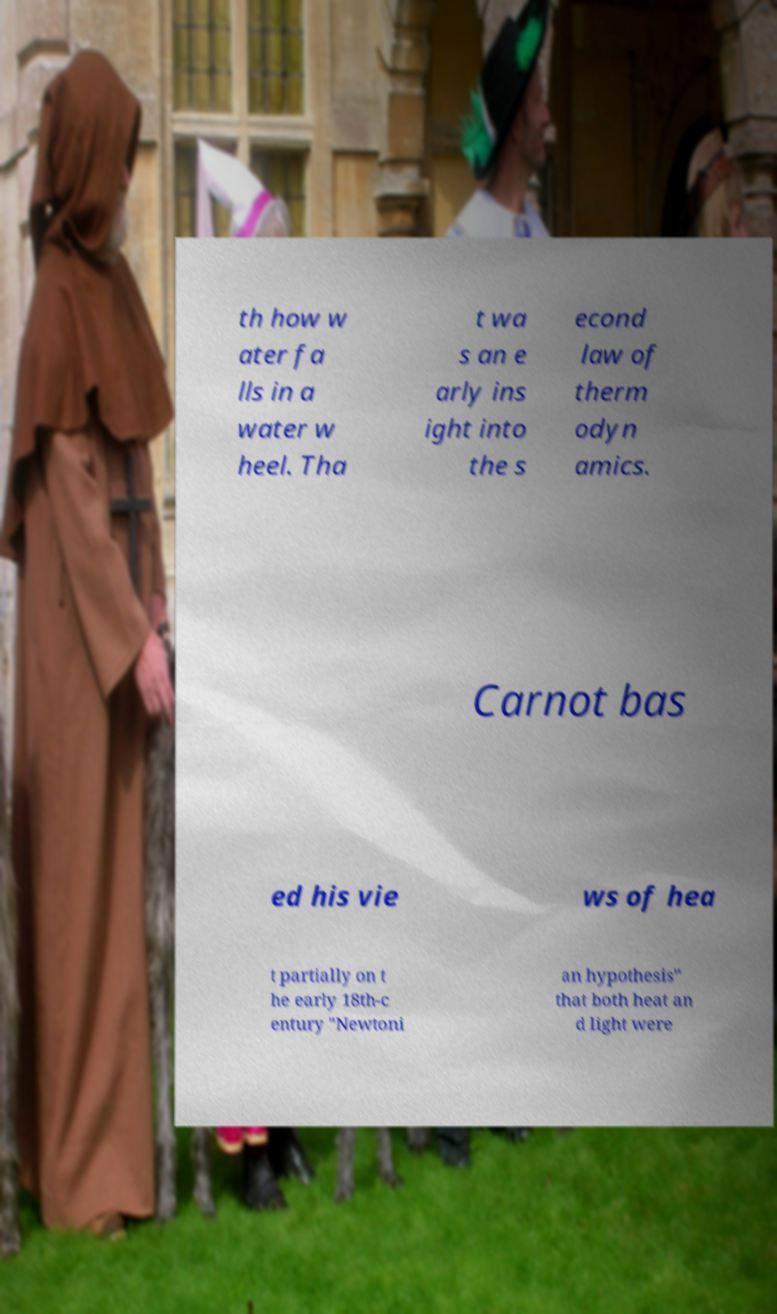Please read and relay the text visible in this image. What does it say? th how w ater fa lls in a water w heel. Tha t wa s an e arly ins ight into the s econd law of therm odyn amics. Carnot bas ed his vie ws of hea t partially on t he early 18th-c entury "Newtoni an hypothesis" that both heat an d light were 